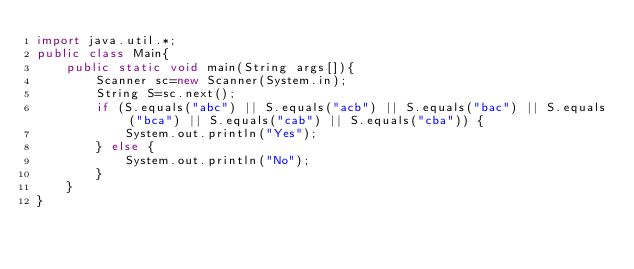Convert code to text. <code><loc_0><loc_0><loc_500><loc_500><_Java_>import java.util.*;
public class Main{
    public static void main(String args[]){
        Scanner sc=new Scanner(System.in);
        String S=sc.next();
        if (S.equals("abc") || S.equals("acb") || S.equals("bac") || S.equals("bca") || S.equals("cab") || S.equals("cba")) {
            System.out.println("Yes");
        } else {
            System.out.println("No");
        }
    }
}</code> 